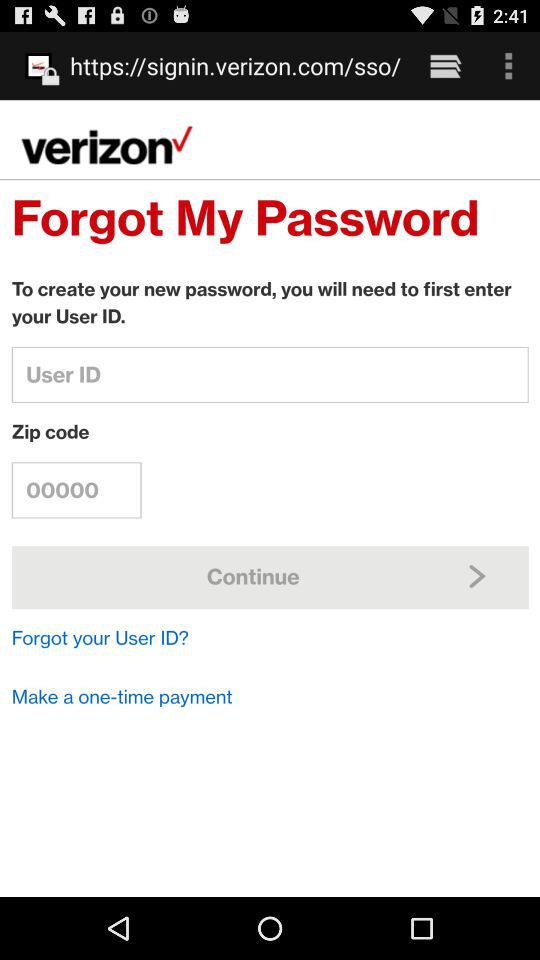What's the Zip code? The Zip code is 00000. 